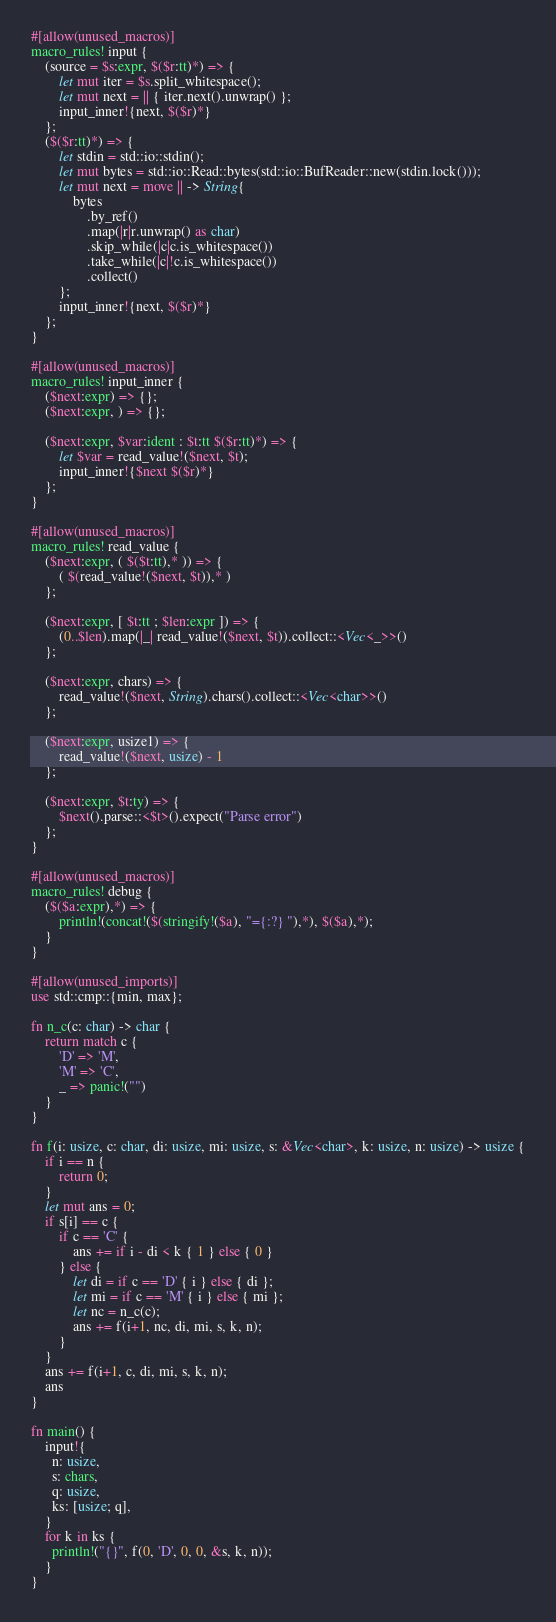Convert code to text. <code><loc_0><loc_0><loc_500><loc_500><_Rust_>#[allow(unused_macros)]
macro_rules! input {
    (source = $s:expr, $($r:tt)*) => {
        let mut iter = $s.split_whitespace();
        let mut next = || { iter.next().unwrap() };
        input_inner!{next, $($r)*}
    };
    ($($r:tt)*) => {
        let stdin = std::io::stdin();
        let mut bytes = std::io::Read::bytes(std::io::BufReader::new(stdin.lock()));
        let mut next = move || -> String{
            bytes
                .by_ref()
                .map(|r|r.unwrap() as char)
                .skip_while(|c|c.is_whitespace())
                .take_while(|c|!c.is_whitespace())
                .collect()
        };
        input_inner!{next, $($r)*}
    };
}

#[allow(unused_macros)]
macro_rules! input_inner {
    ($next:expr) => {};
    ($next:expr, ) => {};

    ($next:expr, $var:ident : $t:tt $($r:tt)*) => {
        let $var = read_value!($next, $t);
        input_inner!{$next $($r)*}
    };
}

#[allow(unused_macros)]
macro_rules! read_value {
    ($next:expr, ( $($t:tt),* )) => {
        ( $(read_value!($next, $t)),* )
    };

    ($next:expr, [ $t:tt ; $len:expr ]) => {
        (0..$len).map(|_| read_value!($next, $t)).collect::<Vec<_>>()
    };

    ($next:expr, chars) => {
        read_value!($next, String).chars().collect::<Vec<char>>()
    };

    ($next:expr, usize1) => {
        read_value!($next, usize) - 1
    };

    ($next:expr, $t:ty) => {
        $next().parse::<$t>().expect("Parse error")
    };
}

#[allow(unused_macros)]
macro_rules! debug {
    ($($a:expr),*) => {
        println!(concat!($(stringify!($a), "={:?} "),*), $($a),*);
    }
}

#[allow(unused_imports)]
use std::cmp::{min, max};

fn n_c(c: char) -> char {
    return match c {
        'D' => 'M',
        'M' => 'C',
        _ => panic!("")
    }
}

fn f(i: usize, c: char, di: usize, mi: usize, s: &Vec<char>, k: usize, n: usize) -> usize {
    if i == n {
        return 0;
    }
    let mut ans = 0;
    if s[i] == c {
        if c == 'C' {
            ans += if i - di < k { 1 } else { 0 }
        } else {
            let di = if c == 'D' { i } else { di };
            let mi = if c == 'M' { i } else { mi };
            let nc = n_c(c);
            ans += f(i+1, nc, di, mi, s, k, n);
        }
    }
    ans += f(i+1, c, di, mi, s, k, n);
    ans
}

fn main() {
    input!{
      n: usize,
      s: chars,
      q: usize,
      ks: [usize; q],
    }
    for k in ks {
      println!("{}", f(0, 'D', 0, 0, &s, k, n));
    }
}
</code> 